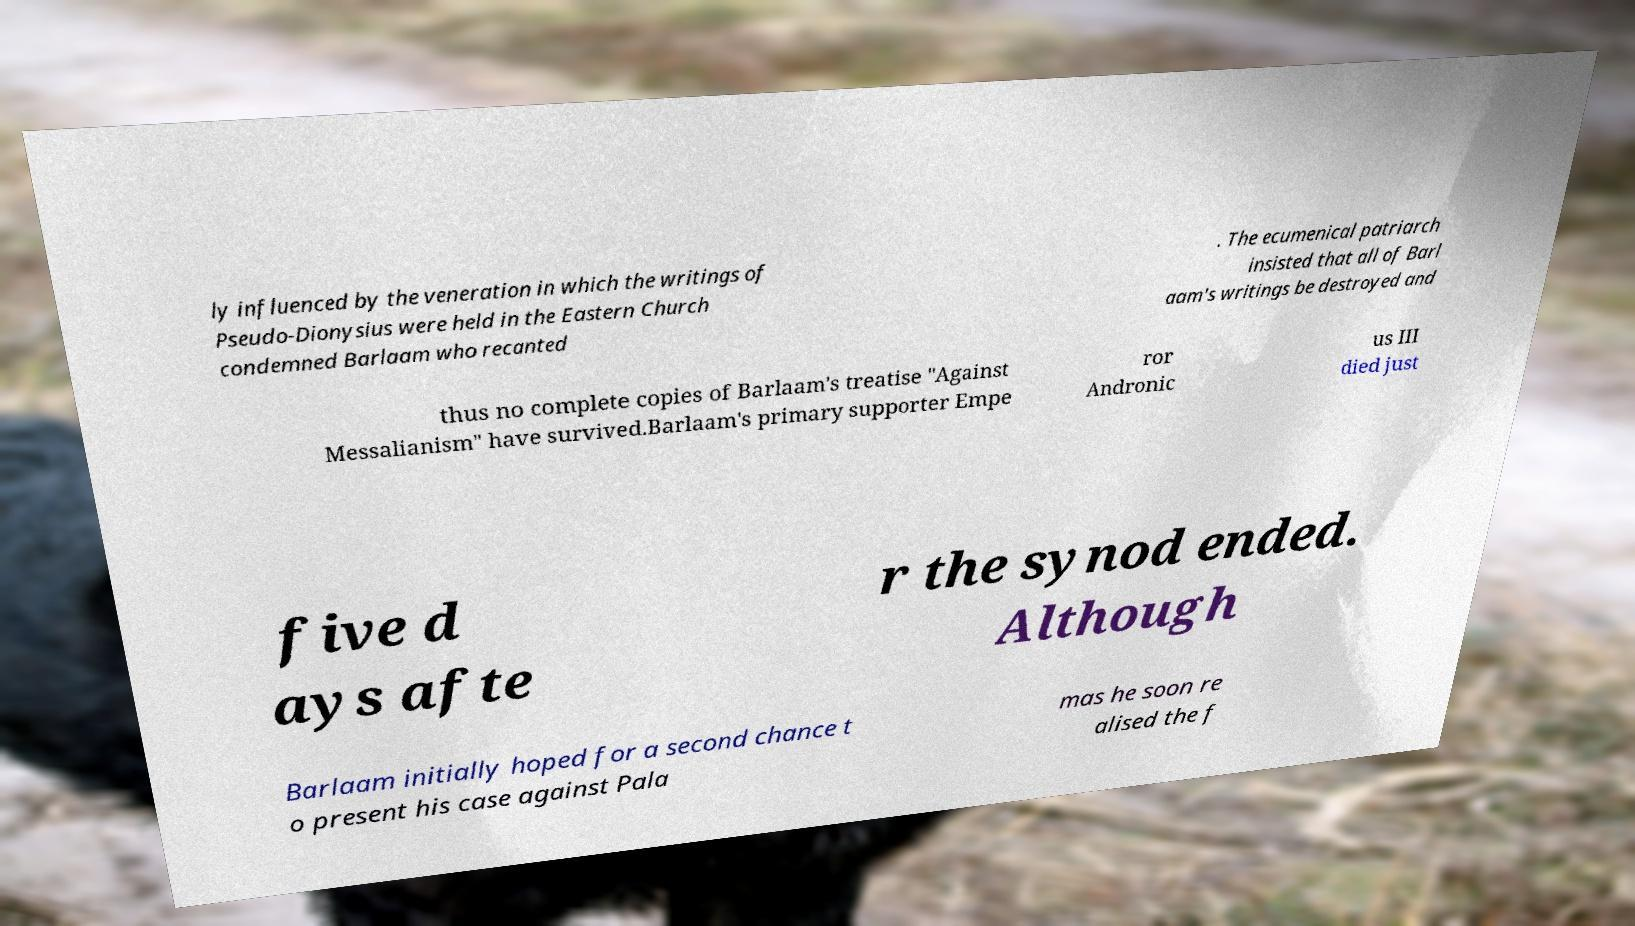Please identify and transcribe the text found in this image. ly influenced by the veneration in which the writings of Pseudo-Dionysius were held in the Eastern Church condemned Barlaam who recanted . The ecumenical patriarch insisted that all of Barl aam's writings be destroyed and thus no complete copies of Barlaam's treatise "Against Messalianism" have survived.Barlaam's primary supporter Empe ror Andronic us III died just five d ays afte r the synod ended. Although Barlaam initially hoped for a second chance t o present his case against Pala mas he soon re alised the f 